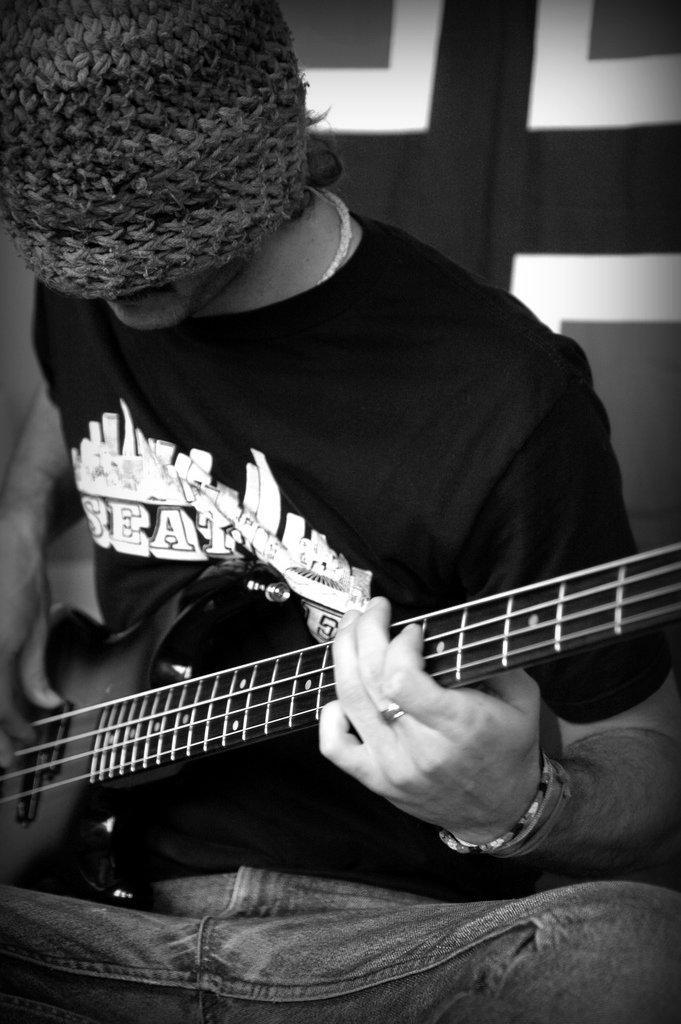Who is in the picture? There is a person in the picture. What is the person doing in the picture? The person is sitting and playing a guitar. What can be seen on the person's head in the picture? The person is wearing a cap. What type of cast can be seen on the person's arm in the image? There is no cast visible on the person's arm in the image. How many times does the person twist the guitar in the image? The person is not twisting the guitar in the image; they are playing it. 